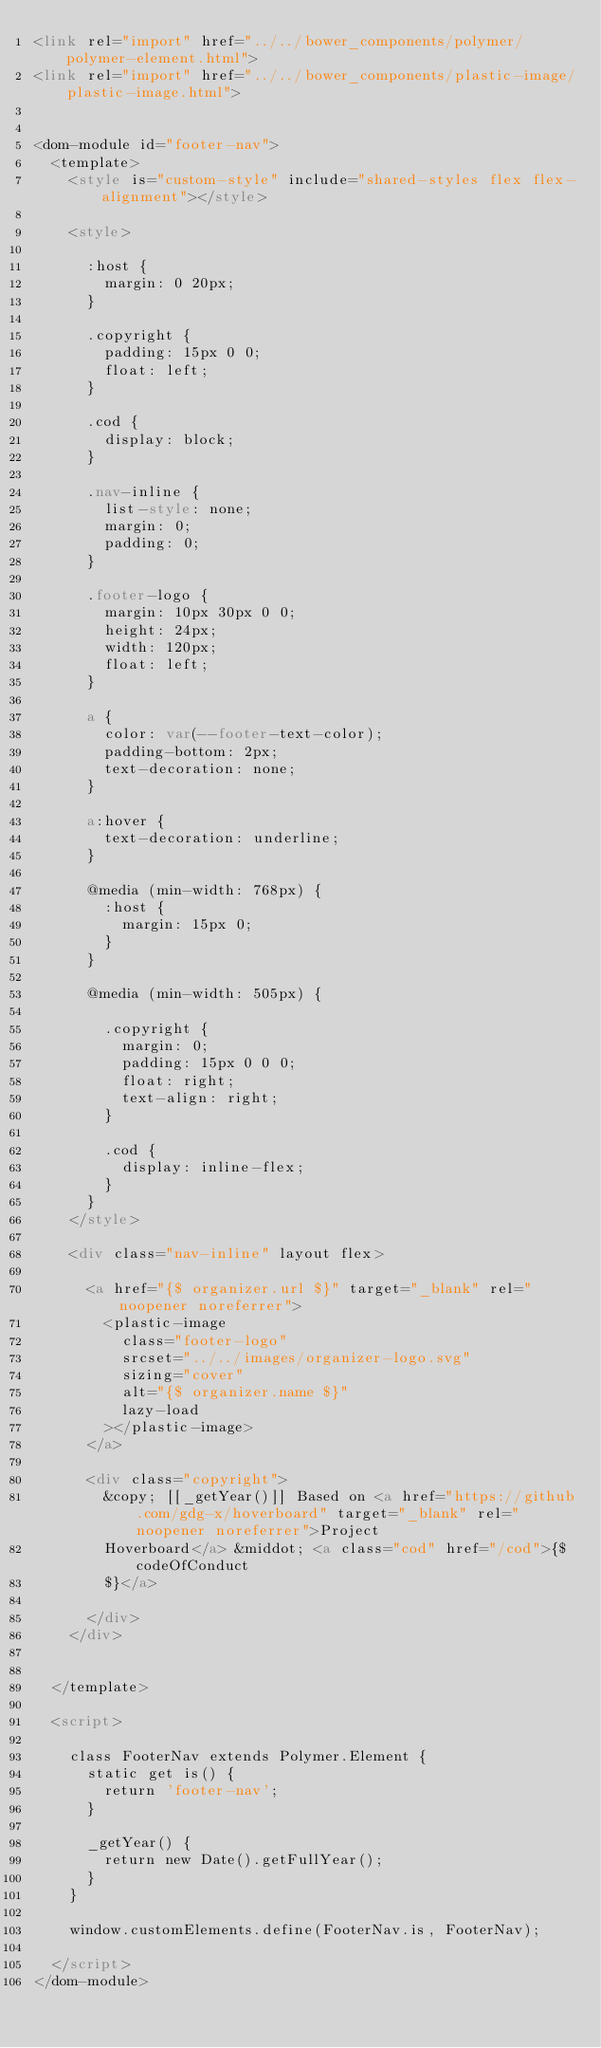Convert code to text. <code><loc_0><loc_0><loc_500><loc_500><_HTML_><link rel="import" href="../../bower_components/polymer/polymer-element.html">
<link rel="import" href="../../bower_components/plastic-image/plastic-image.html">


<dom-module id="footer-nav">
  <template>
    <style is="custom-style" include="shared-styles flex flex-alignment"></style>

    <style>

      :host {
        margin: 0 20px;
      }

      .copyright {
        padding: 15px 0 0;
        float: left;
      }

      .cod {
        display: block;
      }

      .nav-inline {
        list-style: none;
        margin: 0;
        padding: 0;
      }

      .footer-logo {
        margin: 10px 30px 0 0;
        height: 24px;
        width: 120px;
        float: left;
      }

      a {
        color: var(--footer-text-color);
        padding-bottom: 2px;
        text-decoration: none;
      }

      a:hover {
        text-decoration: underline;
      }

      @media (min-width: 768px) {
        :host {
          margin: 15px 0;
        }
      }

      @media (min-width: 505px) {

        .copyright {
          margin: 0;
          padding: 15px 0 0 0;
          float: right;
          text-align: right;
        }

        .cod {
          display: inline-flex;
        }
      }
    </style>

    <div class="nav-inline" layout flex>

      <a href="{$ organizer.url $}" target="_blank" rel="noopener noreferrer">
        <plastic-image
          class="footer-logo"
          srcset="../../images/organizer-logo.svg"
          sizing="cover"
          alt="{$ organizer.name $}"
          lazy-load
        ></plastic-image>
      </a>

      <div class="copyright">
        &copy; [[_getYear()]] Based on <a href="https://github.com/gdg-x/hoverboard" target="_blank" rel="noopener noreferrer">Project
        Hoverboard</a> &middot; <a class="cod" href="/cod">{$ codeOfConduct
        $}</a>

      </div>
    </div>


  </template>

  <script>

    class FooterNav extends Polymer.Element {
      static get is() {
        return 'footer-nav';
      }

      _getYear() {
        return new Date().getFullYear();
      }
    }

    window.customElements.define(FooterNav.is, FooterNav);

  </script>
</dom-module>

</code> 